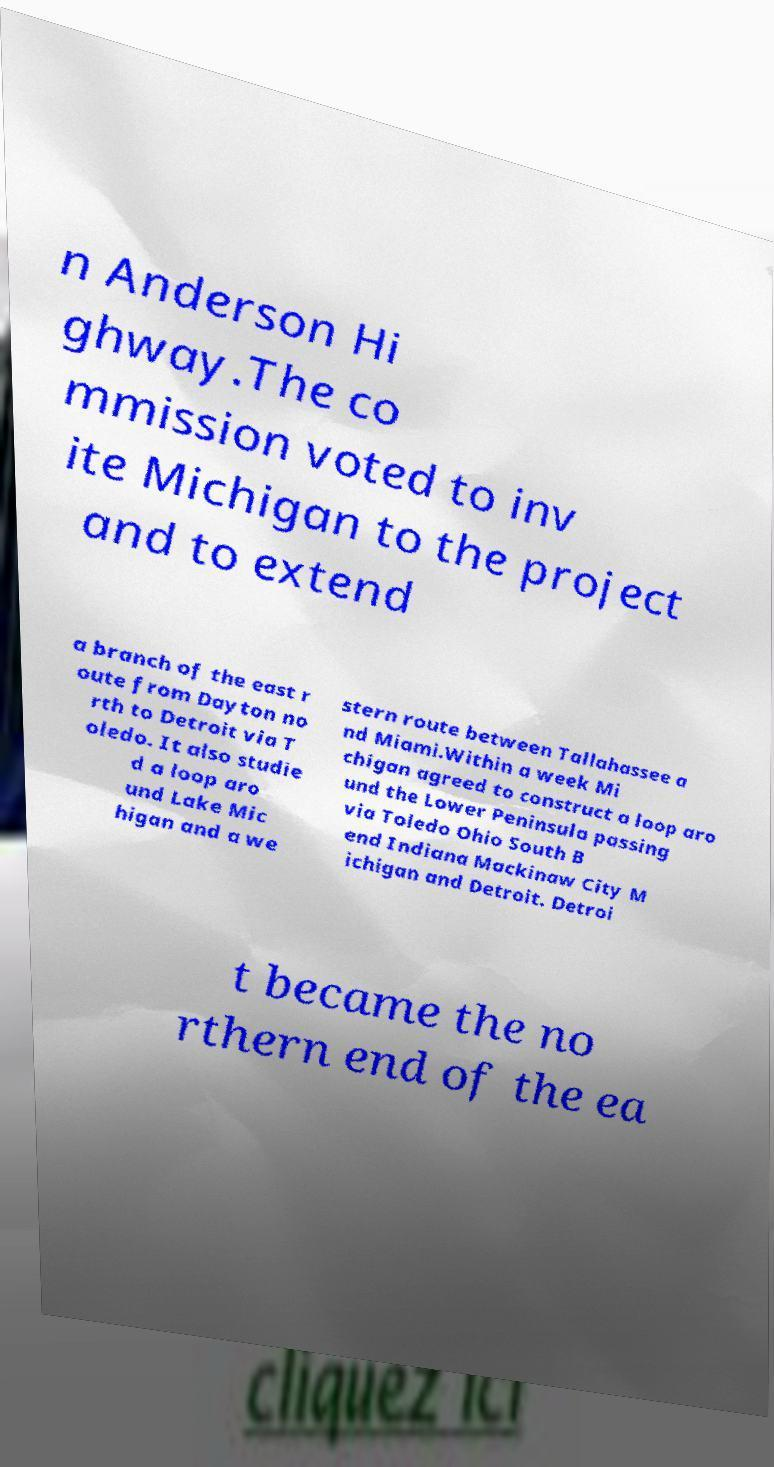I need the written content from this picture converted into text. Can you do that? n Anderson Hi ghway.The co mmission voted to inv ite Michigan to the project and to extend a branch of the east r oute from Dayton no rth to Detroit via T oledo. It also studie d a loop aro und Lake Mic higan and a we stern route between Tallahassee a nd Miami.Within a week Mi chigan agreed to construct a loop aro und the Lower Peninsula passing via Toledo Ohio South B end Indiana Mackinaw City M ichigan and Detroit. Detroi t became the no rthern end of the ea 